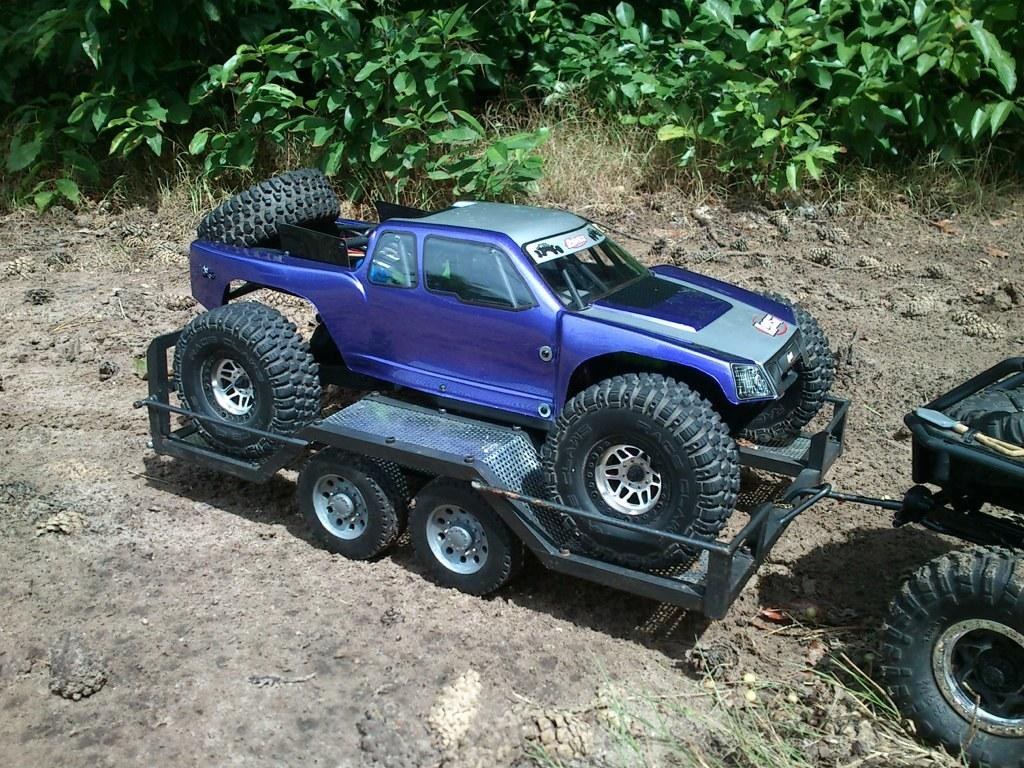What types of objects are on the ground in the image? There are vehicles on the ground in the image. What can be seen in the distance in the image? There are trees in the background of the image. What type of wax is being used to polish the vehicles in the image? There is no indication in the image that the vehicles are being polished with wax, so it cannot be determined from the picture. 